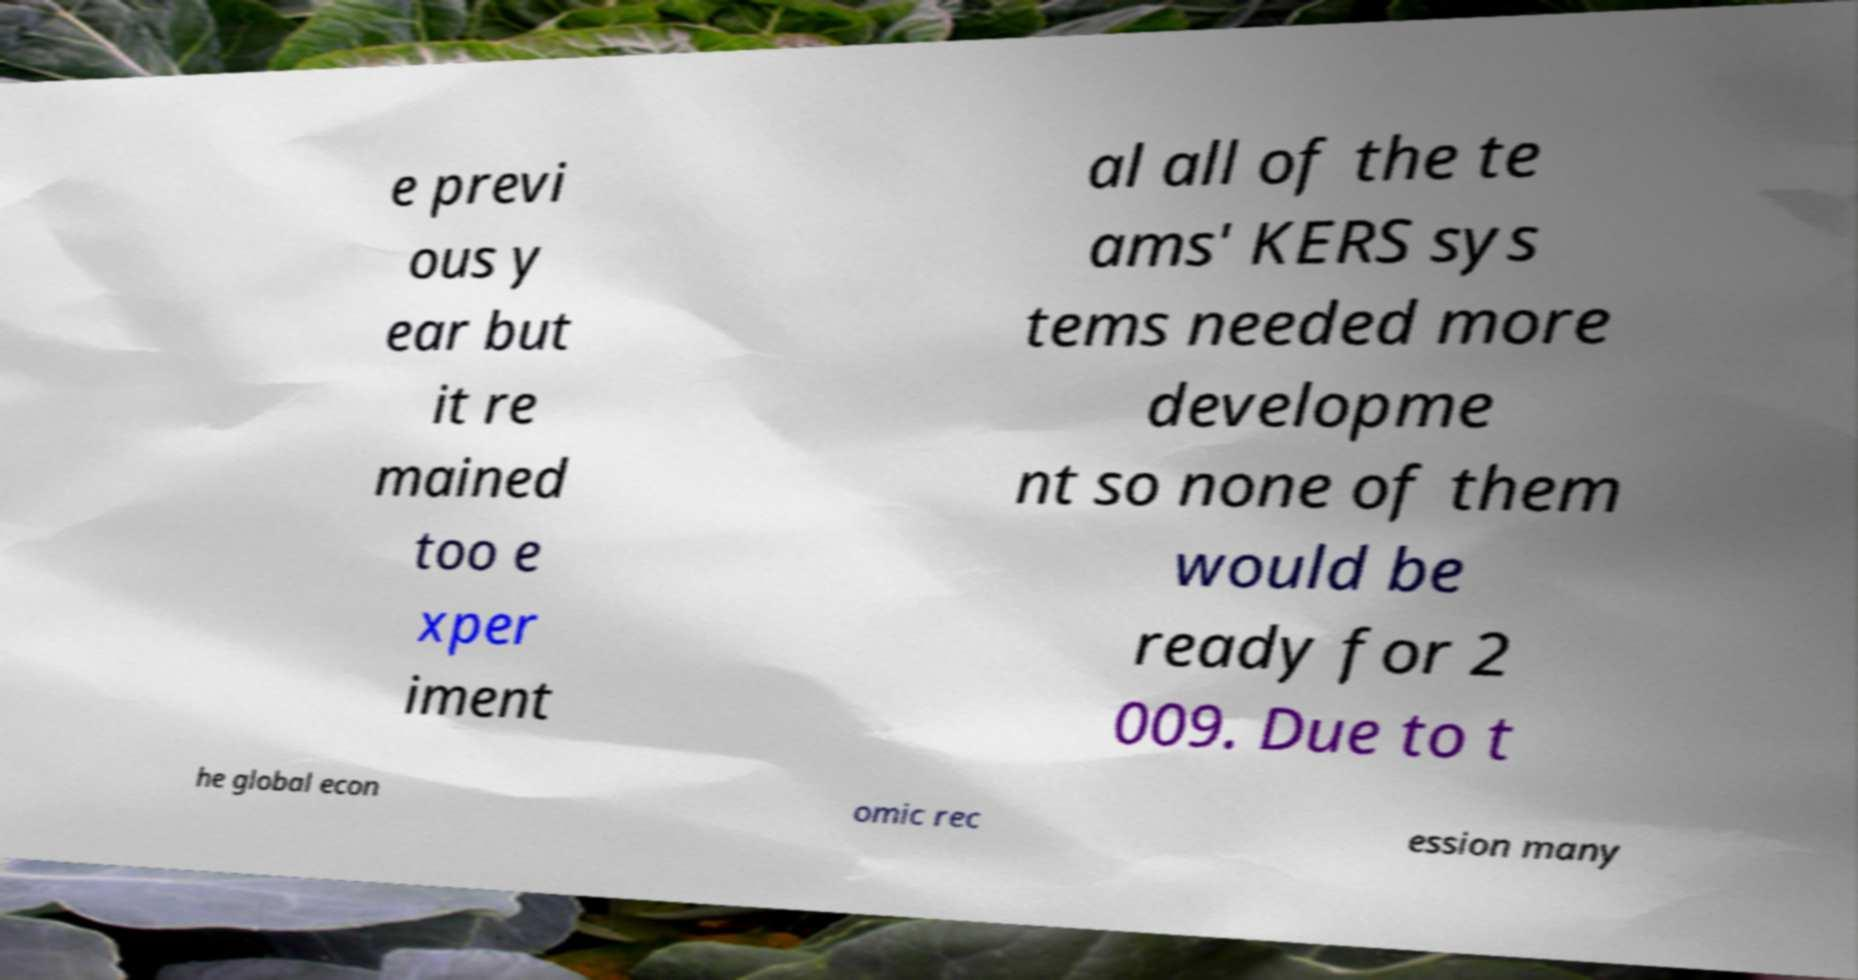What messages or text are displayed in this image? I need them in a readable, typed format. e previ ous y ear but it re mained too e xper iment al all of the te ams' KERS sys tems needed more developme nt so none of them would be ready for 2 009. Due to t he global econ omic rec ession many 